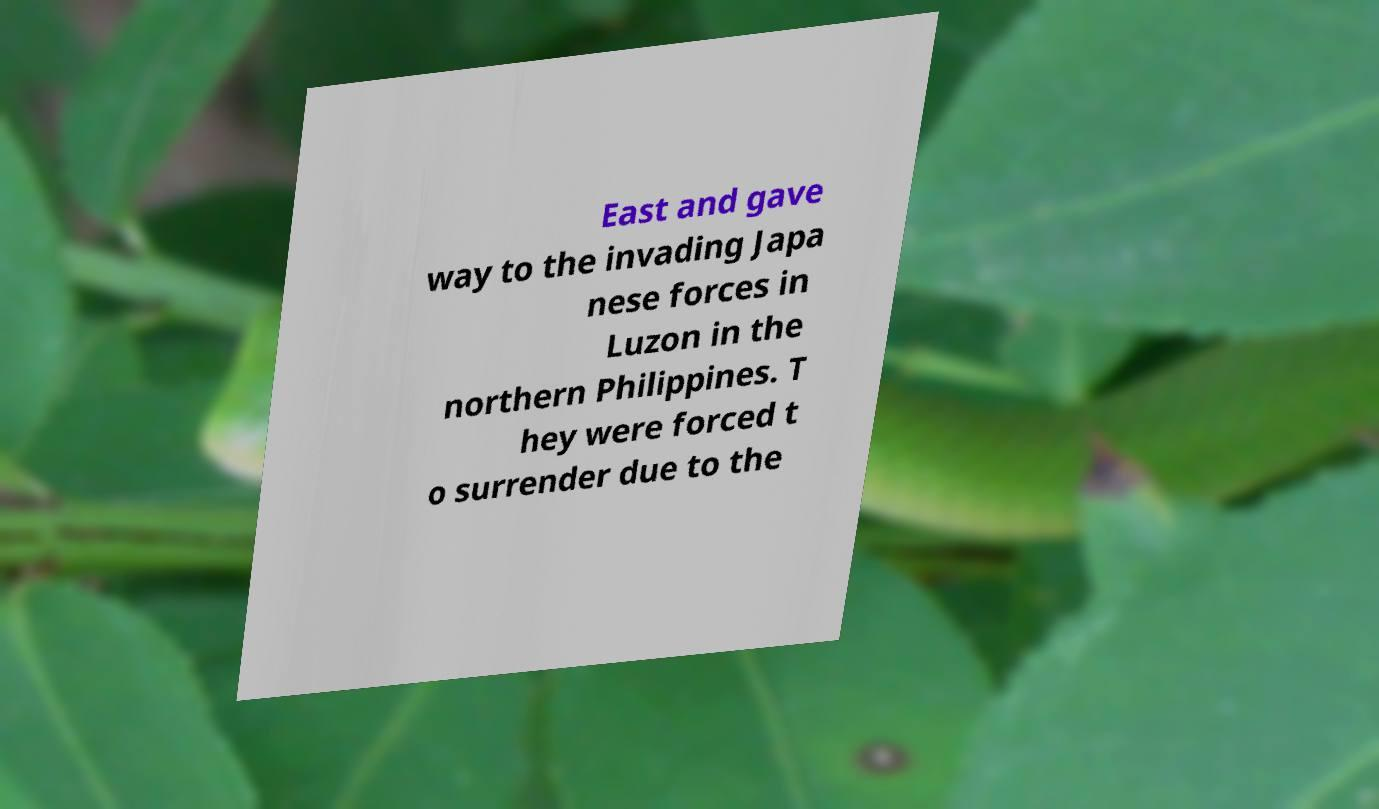There's text embedded in this image that I need extracted. Can you transcribe it verbatim? East and gave way to the invading Japa nese forces in Luzon in the northern Philippines. T hey were forced t o surrender due to the 